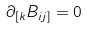Convert formula to latex. <formula><loc_0><loc_0><loc_500><loc_500>\partial _ { [ k } B _ { i j ] } = 0</formula> 